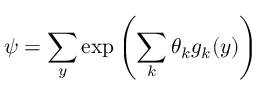Convert formula to latex. <formula><loc_0><loc_0><loc_500><loc_500>\psi = \sum _ { y } \exp \left ( \sum _ { k } \theta _ { k } g _ { k } ( y ) \right )</formula> 